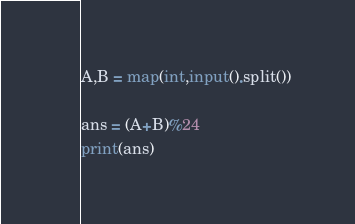<code> <loc_0><loc_0><loc_500><loc_500><_Python_>A,B = map(int,input().split())

ans = (A+B)%24
print(ans)
</code> 